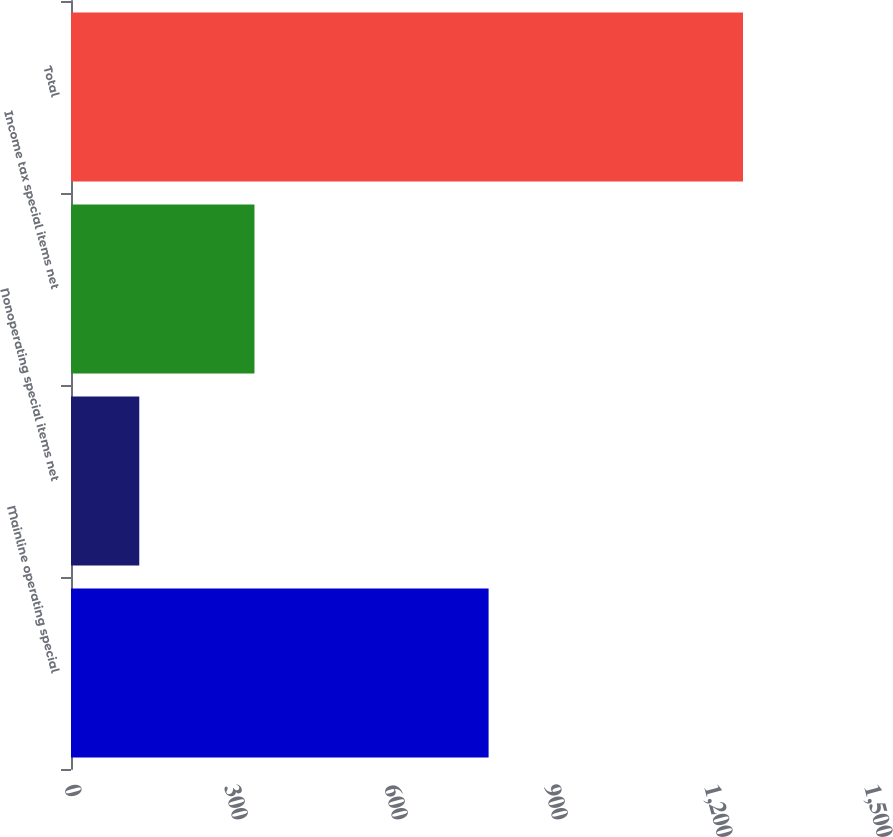Convert chart. <chart><loc_0><loc_0><loc_500><loc_500><bar_chart><fcel>Mainline operating special<fcel>Nonoperating special items net<fcel>Income tax special items net<fcel>Total<nl><fcel>783<fcel>128<fcel>344<fcel>1260<nl></chart> 